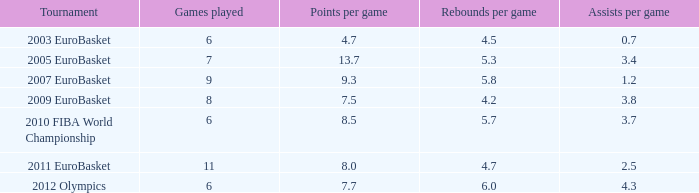How may assists per game have 7.7 points per game? 4.3. 